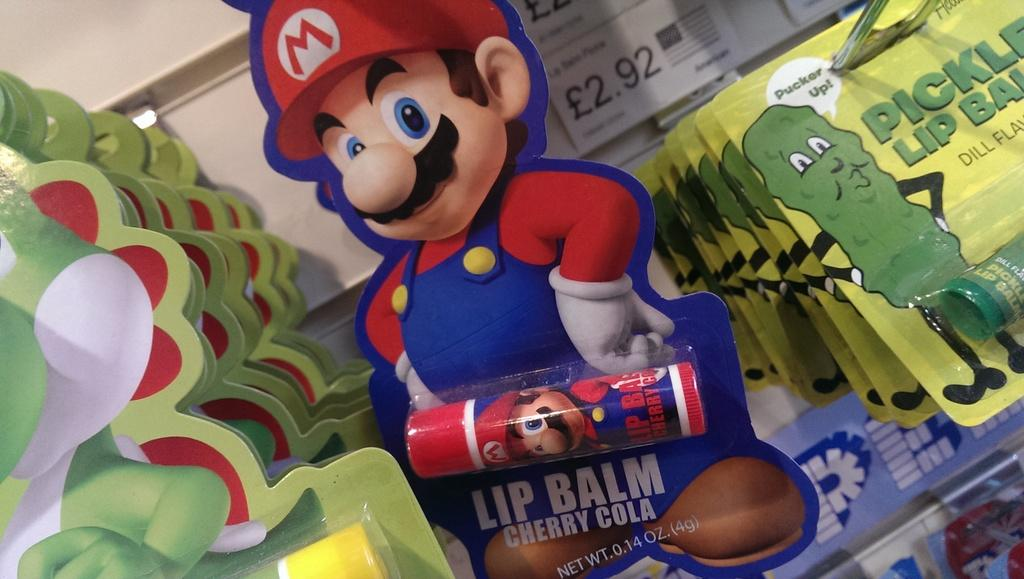What type of product can be seen in the image? There are lip balms in the image. How are the lip balms displayed? The lip balms are attached to cartoon boards. Are there any indications of the price of the lip balms in the image? Yes, there are price tags in the image. Where are the price tags located? The price tags are attached to the wall. What type of corn can be seen growing on the wall in the image? There is no corn present in the image; it features lip balms attached to cartoon boards and price tags on the wall. 